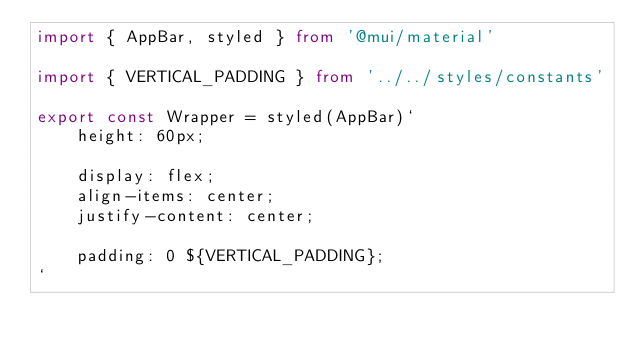<code> <loc_0><loc_0><loc_500><loc_500><_TypeScript_>import { AppBar, styled } from '@mui/material'

import { VERTICAL_PADDING } from '../../styles/constants'

export const Wrapper = styled(AppBar)`
    height: 60px;

    display: flex;
    align-items: center;
    justify-content: center;

    padding: 0 ${VERTICAL_PADDING};
`
</code> 